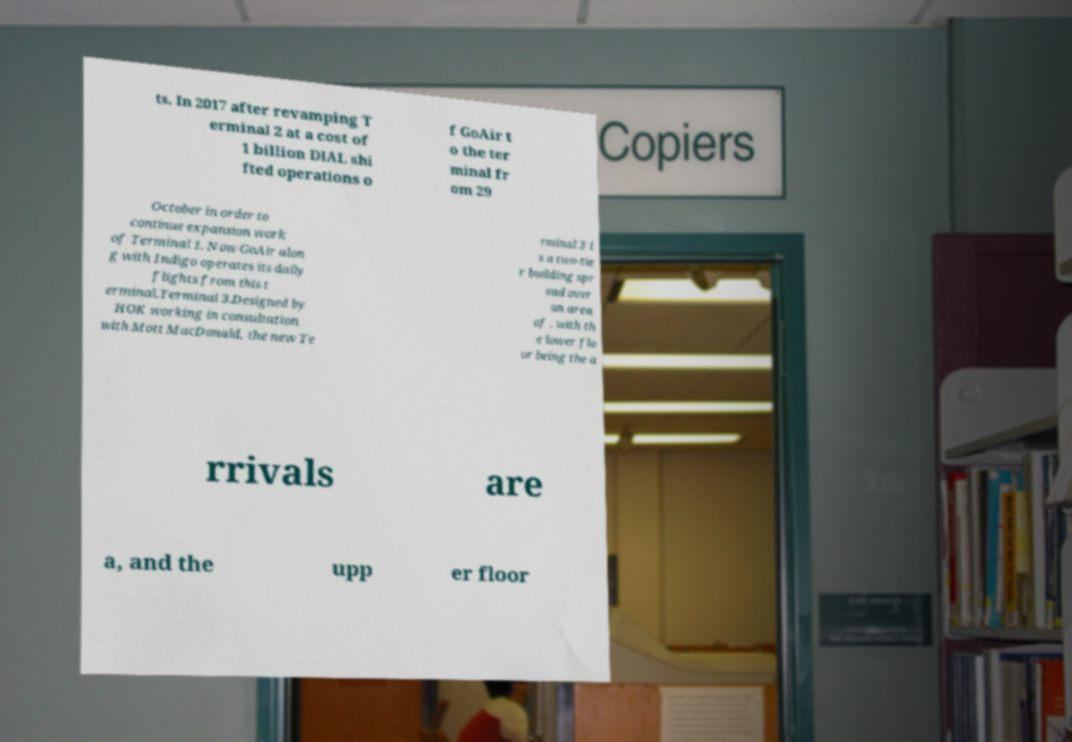What messages or text are displayed in this image? I need them in a readable, typed format. ts. In 2017 after revamping T erminal 2 at a cost of 1 billion DIAL shi fted operations o f GoAir t o the ter minal fr om 29 October in order to continue expansion work of Terminal 1. Now GoAir alon g with Indigo operates its daily flights from this t erminal.Terminal 3.Designed by HOK working in consultation with Mott MacDonald, the new Te rminal 3 i s a two-tie r building spr ead over an area of , with th e lower flo or being the a rrivals are a, and the upp er floor 